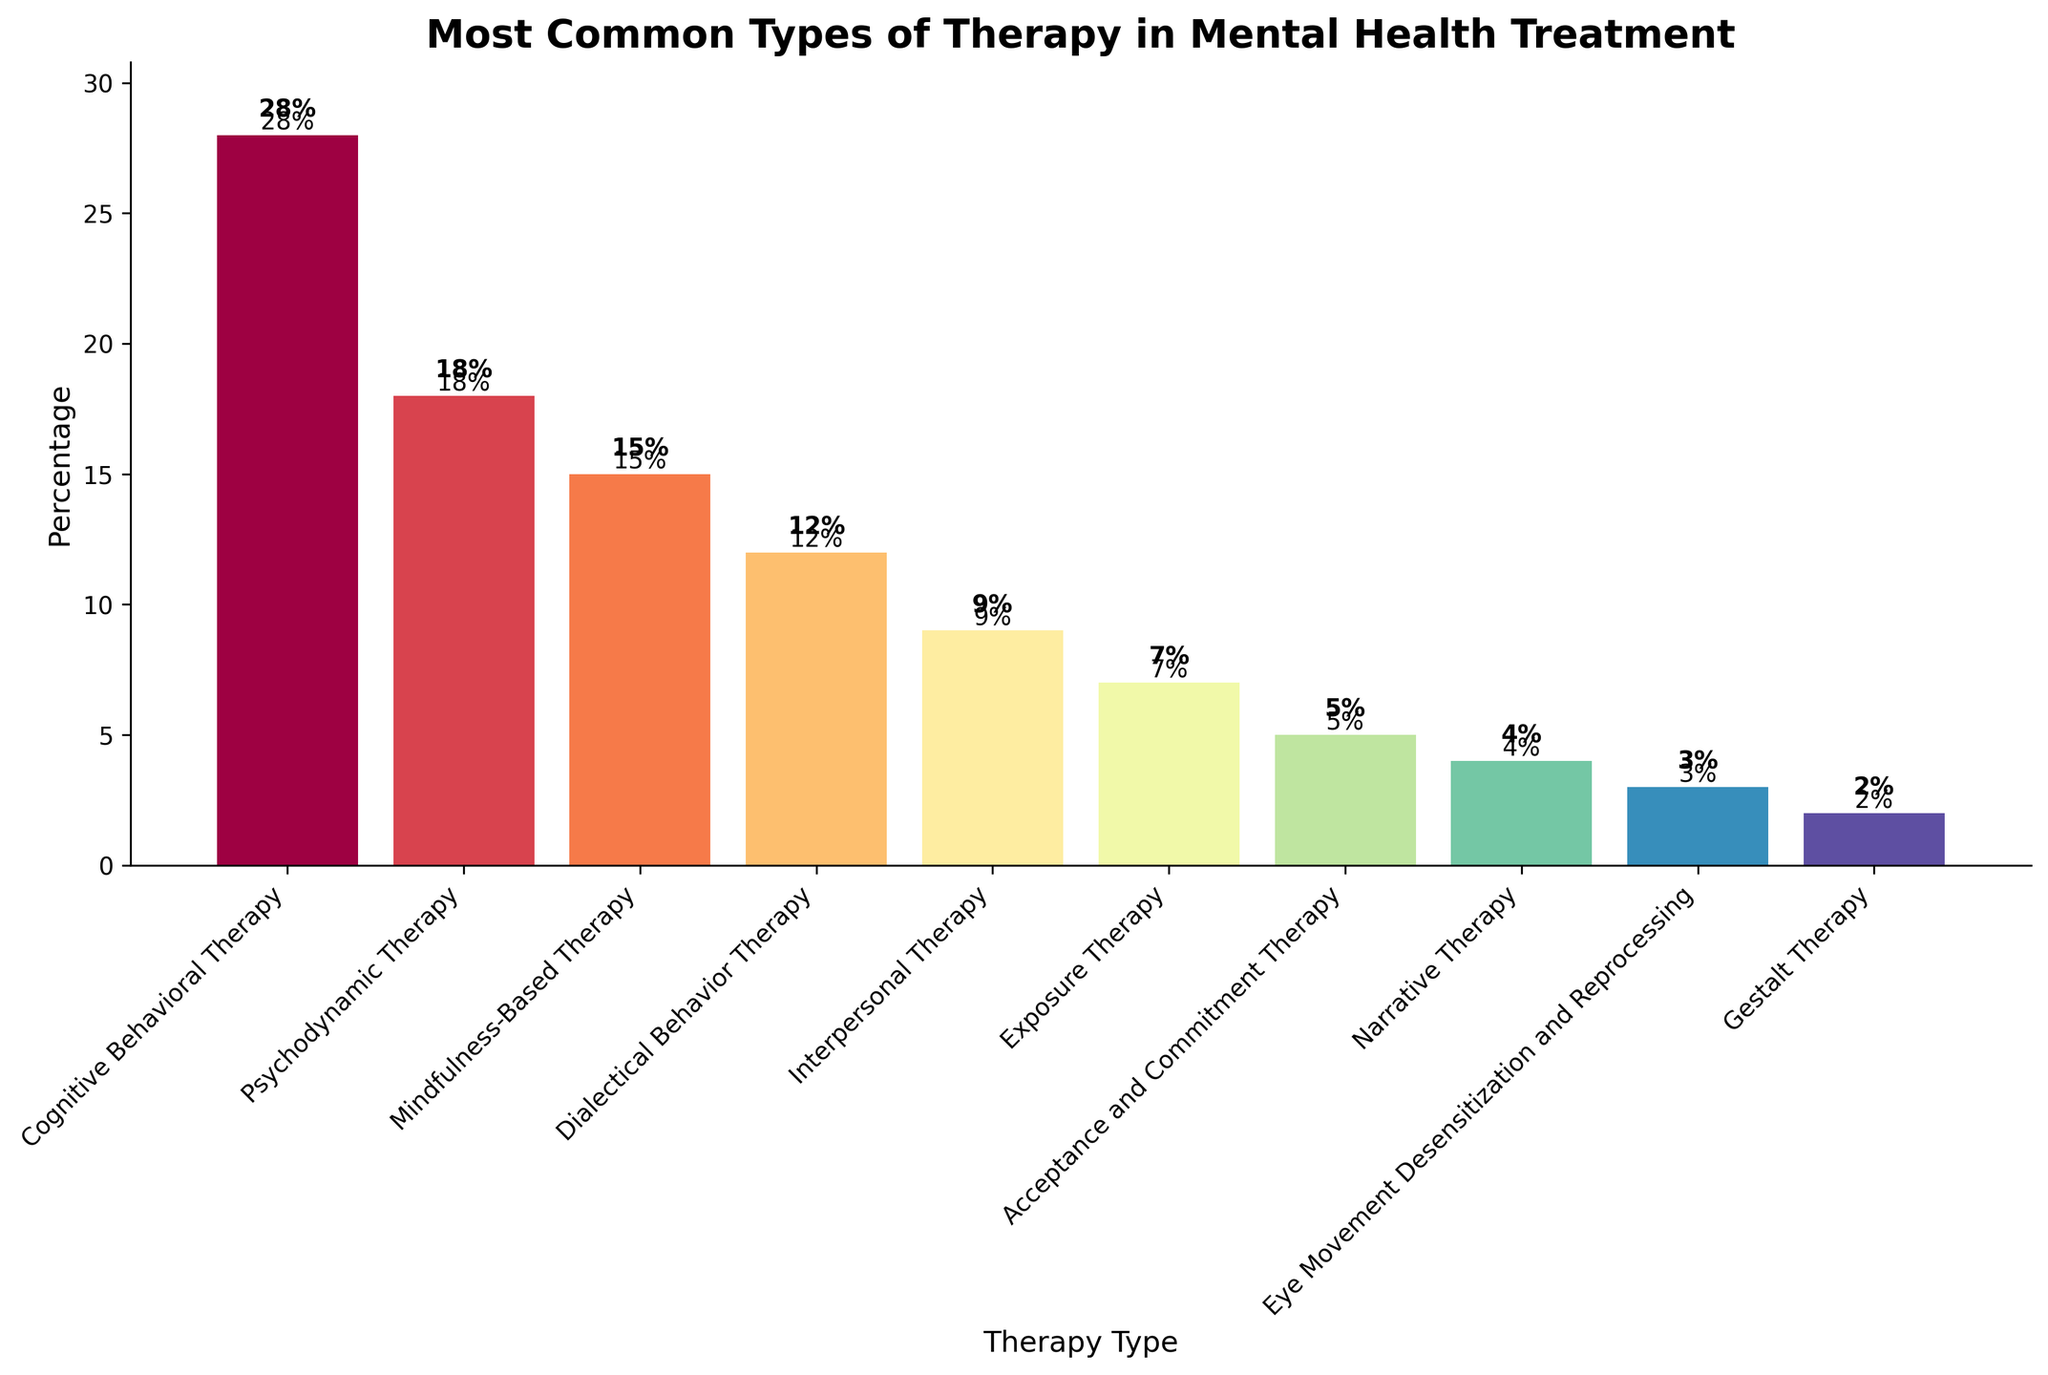What are the top three most common types of therapy? To determine the top three most common types, look at the heights of the bars and identify the highest three. They are Cognitive Behavioral Therapy (28%), Psychodynamic Therapy (18%), and Mindfulness-Based Therapy (15%).
Answer: Cognitive Behavioral Therapy, Psychodynamic Therapy, Mindfulness-Based Therapy Which therapy is used less often, Interpersonal Therapy or Exposure Therapy? Compare the heights of the bars for Interpersonal Therapy and Exposure Therapy. Interpersonal Therapy is at 9% and Exposure Therapy is at 7%, so Exposure Therapy is used less often.
Answer: Exposure Therapy How much more common is Cognitive Behavioral Therapy compared to Gestalt Therapy? Subtract the percentage of Gestalt Therapy (2%) from the percentage of Cognitive Behavioral Therapy (28%). 28% - 2% = 26%.
Answer: 26% Which type of therapy is represented by the shortest bar? Identify the shortest bar in the bar chart. The shortest bar represents Gestalt Therapy which is at 2%.
Answer: Gestalt Therapy What is the average percentage of all therapy types listed? Add all the percentages and divide by the number of therapy types. (28 + 18 + 15 + 12 + 9 + 7 + 5 + 4 + 3 + 2) / 10 = 10.3%.
Answer: 10.3% Which therapy types constitute more than 20% of the total? Identify which bars have heights greater than 20%. Only Cognitive Behavioral Therapy at 28% meets this criterion.
Answer: Cognitive Behavioral Therapy How many therapy types have a percentage less than 10%? Count the number of bars that are below the 10% mark. They are Interpersonal Therapy (9%), Exposure Therapy (7%), Acceptance and Commitment Therapy (5%), Narrative Therapy (4%), Eye Movement Desensitization and Reprocessing (3%), and Gestalt Therapy (2%). This sums up to 6 therapy types.
Answer: 6 Which therapy type has the closest percentage to Dialectical Behavior Therapy? Compare percentages of all therapy types to find the one closest to 12%, which is the percentage for Dialectical Behavior Therapy. Mindfulness-Based Therapy, at 15%, is the closest.
Answer: Mindfulness-Based Therapy 